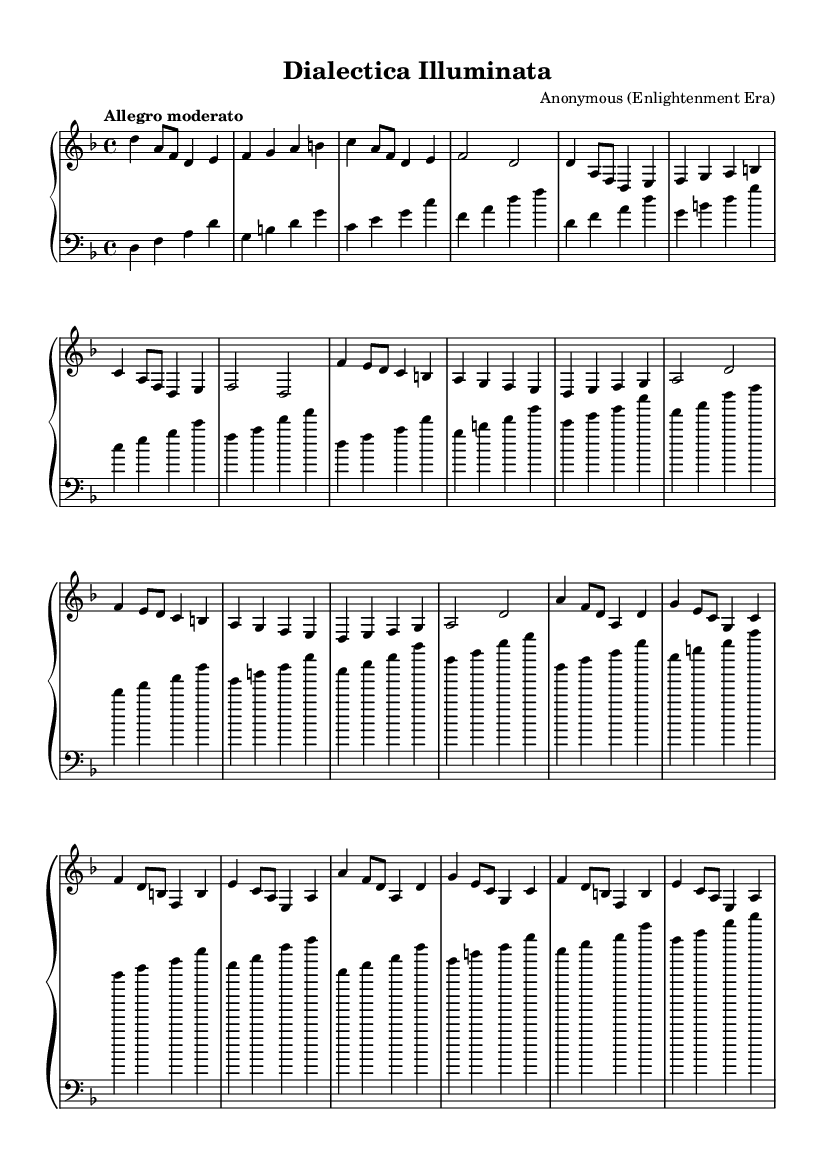What is the key signature of this music? The key signature is D minor, indicated by one flat (B flat). It is identified on the staff prior to the beginning of the notes.
Answer: D minor What is the time signature of this music? The time signature is 4/4, indicated at the start of the piece. This means there are 4 beats in each measure and the quarter note receives one beat.
Answer: 4/4 What is the tempo marking for this piece? The tempo marking is "Allegro moderato," which suggests a moderately fast pace. This is explicitly written above the staff at the beginning of the score.
Answer: Allegro moderato How many sections are there in this composition? The composition consists of three sections: A, B, and C. This can be determined by looking at the structure outlined in the notation.
Answer: 3 In which section does the melody feature a repeated phrase motif? The repeated phrase motif is found in the A section, where the musical ideas are repeated in quick succession, contributing to the thematic unity.
Answer: A What type of musical form does this composition exemplify? The composition exemplifies a ternary form (ABA), where the first section is repeated after contrasting material in the second section. This structure is common in Baroque music.
Answer: Ternary form What is the texture of this piece primarily characterized as? The texture of the piece is primarily homophonic, as the harpsichord melody dominates while the bass provides harmonic support, consistent with Baroque style.
Answer: Homophonic 